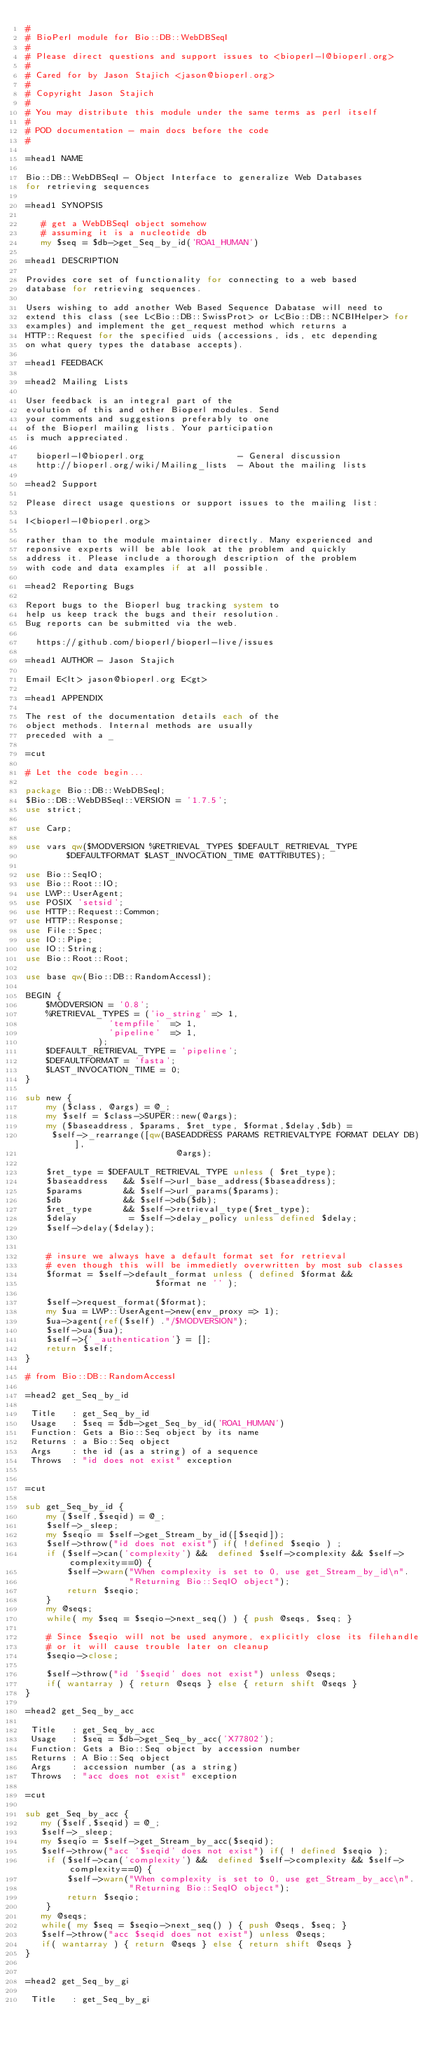Convert code to text. <code><loc_0><loc_0><loc_500><loc_500><_Perl_>#
# BioPerl module for Bio::DB::WebDBSeqI
#
# Please direct questions and support issues to <bioperl-l@bioperl.org>
#
# Cared for by Jason Stajich <jason@bioperl.org>
#
# Copyright Jason Stajich
#
# You may distribute this module under the same terms as perl itself
#
# POD documentation - main docs before the code
#

=head1 NAME

Bio::DB::WebDBSeqI - Object Interface to generalize Web Databases
for retrieving sequences

=head1 SYNOPSIS

   # get a WebDBSeqI object somehow
   # assuming it is a nucleotide db
   my $seq = $db->get_Seq_by_id('ROA1_HUMAN')

=head1 DESCRIPTION

Provides core set of functionality for connecting to a web based
database for retrieving sequences.

Users wishing to add another Web Based Sequence Dabatase will need to
extend this class (see L<Bio::DB::SwissProt> or L<Bio::DB::NCBIHelper> for
examples) and implement the get_request method which returns a
HTTP::Request for the specified uids (accessions, ids, etc depending
on what query types the database accepts).

=head1 FEEDBACK

=head2 Mailing Lists

User feedback is an integral part of the
evolution of this and other Bioperl modules. Send
your comments and suggestions preferably to one
of the Bioperl mailing lists. Your participation
is much appreciated.

  bioperl-l@bioperl.org                  - General discussion
  http://bioperl.org/wiki/Mailing_lists  - About the mailing lists

=head2 Support

Please direct usage questions or support issues to the mailing list:

I<bioperl-l@bioperl.org>

rather than to the module maintainer directly. Many experienced and
reponsive experts will be able look at the problem and quickly
address it. Please include a thorough description of the problem
with code and data examples if at all possible.

=head2 Reporting Bugs

Report bugs to the Bioperl bug tracking system to
help us keep track the bugs and their resolution.
Bug reports can be submitted via the web.

  https://github.com/bioperl/bioperl-live/issues

=head1 AUTHOR - Jason Stajich

Email E<lt> jason@bioperl.org E<gt>

=head1 APPENDIX

The rest of the documentation details each of the
object methods. Internal methods are usually
preceded with a _

=cut

# Let the code begin...

package Bio::DB::WebDBSeqI;
$Bio::DB::WebDBSeqI::VERSION = '1.7.5';
use strict;

use Carp;

use vars qw($MODVERSION %RETRIEVAL_TYPES $DEFAULT_RETRIEVAL_TYPE
	    $DEFAULTFORMAT $LAST_INVOCATION_TIME @ATTRIBUTES);

use Bio::SeqIO;
use Bio::Root::IO;
use LWP::UserAgent;
use POSIX 'setsid';
use HTTP::Request::Common;
use HTTP::Response;
use File::Spec;
use IO::Pipe;
use IO::String;
use Bio::Root::Root;

use base qw(Bio::DB::RandomAccessI);

BEGIN {
	$MODVERSION = '0.8';
	%RETRIEVAL_TYPES = ('io_string' => 1,
			    'tempfile'  => 1,
			    'pipeline'  => 1,
			  );
	$DEFAULT_RETRIEVAL_TYPE = 'pipeline';
	$DEFAULTFORMAT = 'fasta';
	$LAST_INVOCATION_TIME = 0;
}

sub new {
    my ($class, @args) = @_;
    my $self = $class->SUPER::new(@args);
    my ($baseaddress, $params, $ret_type, $format,$delay,$db) =
	 $self->_rearrange([qw(BASEADDRESS PARAMS RETRIEVALTYPE FORMAT DELAY DB)],
							 @args);

    $ret_type = $DEFAULT_RETRIEVAL_TYPE unless ( $ret_type);
    $baseaddress   && $self->url_base_address($baseaddress);
    $params        && $self->url_params($params);
    $db            && $self->db($db);
    $ret_type      && $self->retrieval_type($ret_type);
    $delay          = $self->delay_policy unless defined $delay;
    $self->delay($delay);


    # insure we always have a default format set for retrieval
    # even though this will be immedietly overwritten by most sub classes
    $format = $self->default_format unless ( defined $format &&
					     $format ne '' );

    $self->request_format($format);
    my $ua = LWP::UserAgent->new(env_proxy => 1);
    $ua->agent(ref($self) ."/$MODVERSION");
    $self->ua($ua);
    $self->{'_authentication'} = [];
    return $self;
}

# from Bio::DB::RandomAccessI

=head2 get_Seq_by_id

 Title   : get_Seq_by_id
 Usage   : $seq = $db->get_Seq_by_id('ROA1_HUMAN')
 Function: Gets a Bio::Seq object by its name
 Returns : a Bio::Seq object
 Args    : the id (as a string) of a sequence
 Throws  : "id does not exist" exception


=cut

sub get_Seq_by_id {
    my ($self,$seqid) = @_;
    $self->_sleep;
    my $seqio = $self->get_Stream_by_id([$seqid]);
    $self->throw("id does not exist") if( !defined $seqio ) ;
    if ($self->can('complexity') &&  defined $self->complexity && $self->complexity==0) {
        $self->warn("When complexity is set to 0, use get_Stream_by_id\n".
                    "Returning Bio::SeqIO object");
        return $seqio;
    }
    my @seqs;
    while( my $seq = $seqio->next_seq() ) { push @seqs, $seq; }

    # Since $seqio will not be used anymore, explicitly close its filehandle
    # or it will cause trouble later on cleanup
    $seqio->close;

    $self->throw("id '$seqid' does not exist") unless @seqs;
    if( wantarray ) { return @seqs } else { return shift @seqs }
}

=head2 get_Seq_by_acc

 Title   : get_Seq_by_acc
 Usage   : $seq = $db->get_Seq_by_acc('X77802');
 Function: Gets a Bio::Seq object by accession number
 Returns : A Bio::Seq object
 Args    : accession number (as a string)
 Throws  : "acc does not exist" exception

=cut

sub get_Seq_by_acc {
   my ($self,$seqid) = @_;
   $self->_sleep;
   my $seqio = $self->get_Stream_by_acc($seqid);
   $self->throw("acc '$seqid' does not exist") if( ! defined $seqio );
    if ($self->can('complexity') &&  defined $self->complexity && $self->complexity==0) {
        $self->warn("When complexity is set to 0, use get_Stream_by_acc\n".
                    "Returning Bio::SeqIO object");
        return $seqio;
    }
   my @seqs;
   while( my $seq = $seqio->next_seq() ) { push @seqs, $seq; }
   $self->throw("acc $seqid does not exist") unless @seqs;
   if( wantarray ) { return @seqs } else { return shift @seqs }
}


=head2 get_Seq_by_gi

 Title   : get_Seq_by_gi</code> 